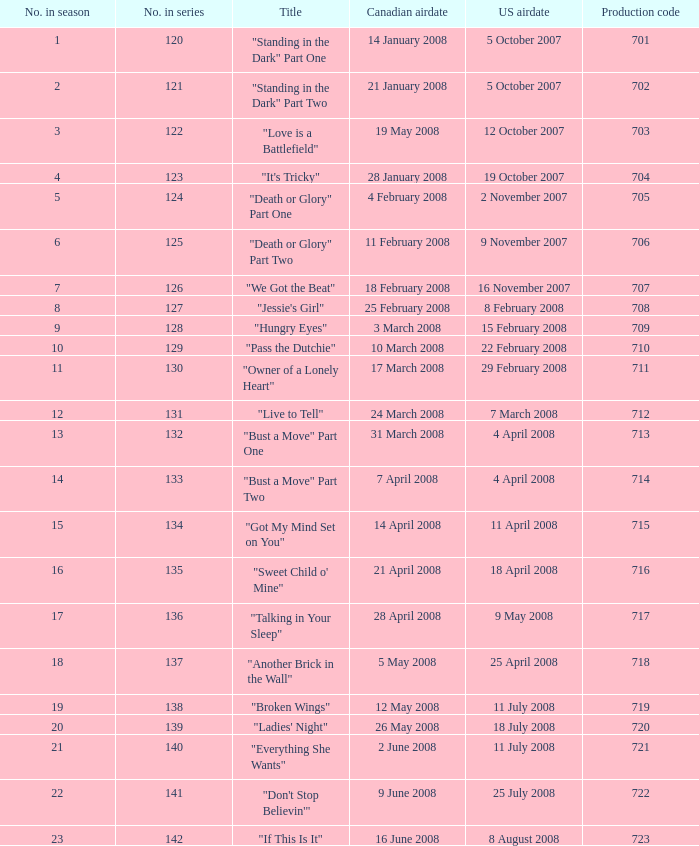The episode titled "don't stop believin'" was what highest number of the season? 22.0. 